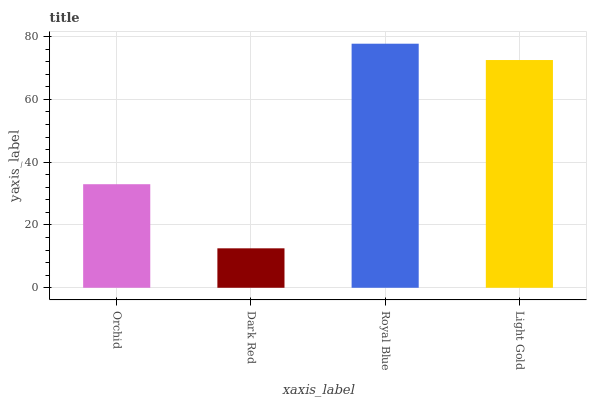Is Dark Red the minimum?
Answer yes or no. Yes. Is Royal Blue the maximum?
Answer yes or no. Yes. Is Royal Blue the minimum?
Answer yes or no. No. Is Dark Red the maximum?
Answer yes or no. No. Is Royal Blue greater than Dark Red?
Answer yes or no. Yes. Is Dark Red less than Royal Blue?
Answer yes or no. Yes. Is Dark Red greater than Royal Blue?
Answer yes or no. No. Is Royal Blue less than Dark Red?
Answer yes or no. No. Is Light Gold the high median?
Answer yes or no. Yes. Is Orchid the low median?
Answer yes or no. Yes. Is Royal Blue the high median?
Answer yes or no. No. Is Light Gold the low median?
Answer yes or no. No. 